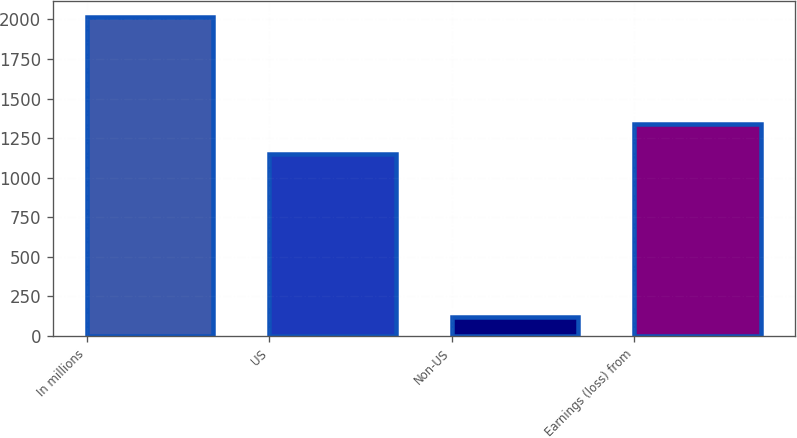Convert chart. <chart><loc_0><loc_0><loc_500><loc_500><bar_chart><fcel>In millions<fcel>US<fcel>Non-US<fcel>Earnings (loss) from<nl><fcel>2015<fcel>1147<fcel>119<fcel>1336.6<nl></chart> 